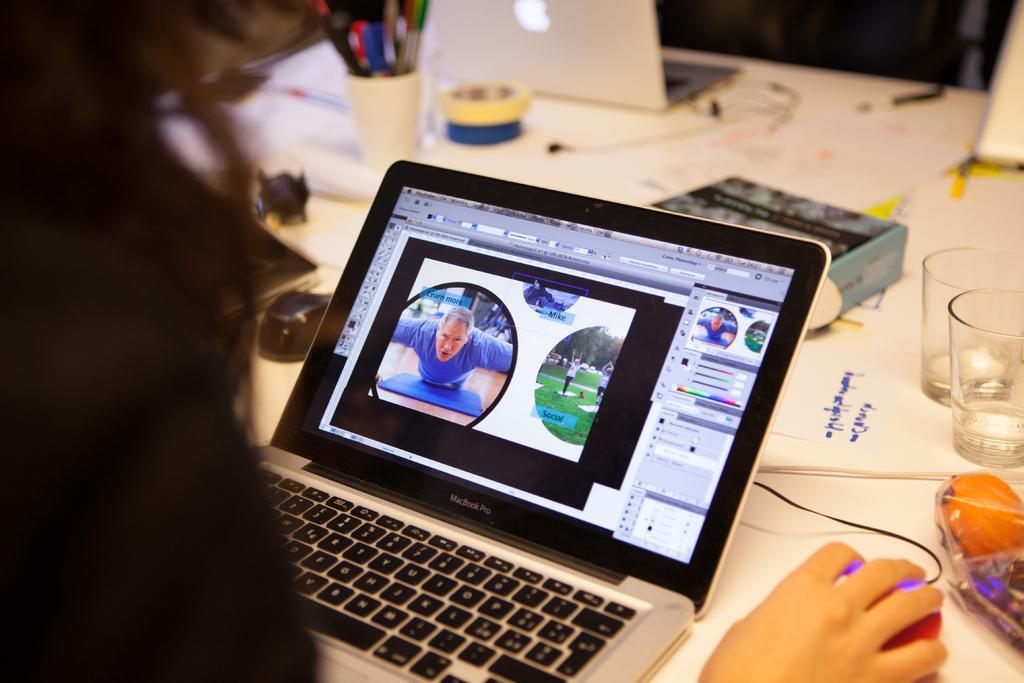Describe this image in one or two sentences. In this image I can see a person is operating a computer mouse. On the table I can see laptops, glasses and other objects. 